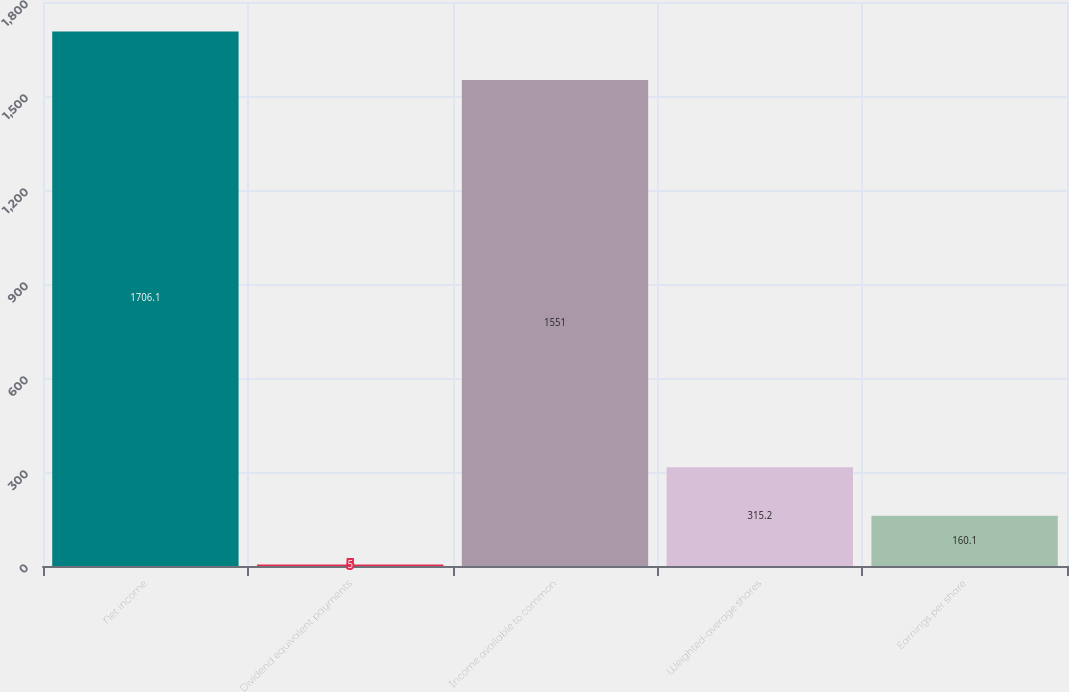Convert chart. <chart><loc_0><loc_0><loc_500><loc_500><bar_chart><fcel>Net income<fcel>Dividend equivalent payments<fcel>Income available to common<fcel>Weighted-average shares<fcel>Earnings per share<nl><fcel>1706.1<fcel>5<fcel>1551<fcel>315.2<fcel>160.1<nl></chart> 